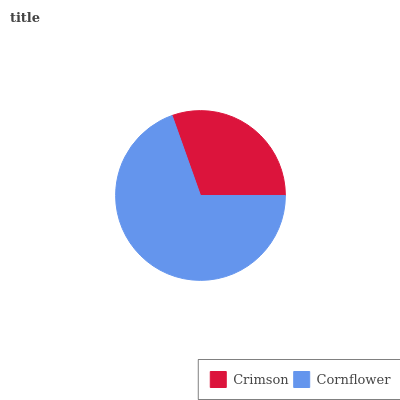Is Crimson the minimum?
Answer yes or no. Yes. Is Cornflower the maximum?
Answer yes or no. Yes. Is Cornflower the minimum?
Answer yes or no. No. Is Cornflower greater than Crimson?
Answer yes or no. Yes. Is Crimson less than Cornflower?
Answer yes or no. Yes. Is Crimson greater than Cornflower?
Answer yes or no. No. Is Cornflower less than Crimson?
Answer yes or no. No. Is Cornflower the high median?
Answer yes or no. Yes. Is Crimson the low median?
Answer yes or no. Yes. Is Crimson the high median?
Answer yes or no. No. Is Cornflower the low median?
Answer yes or no. No. 